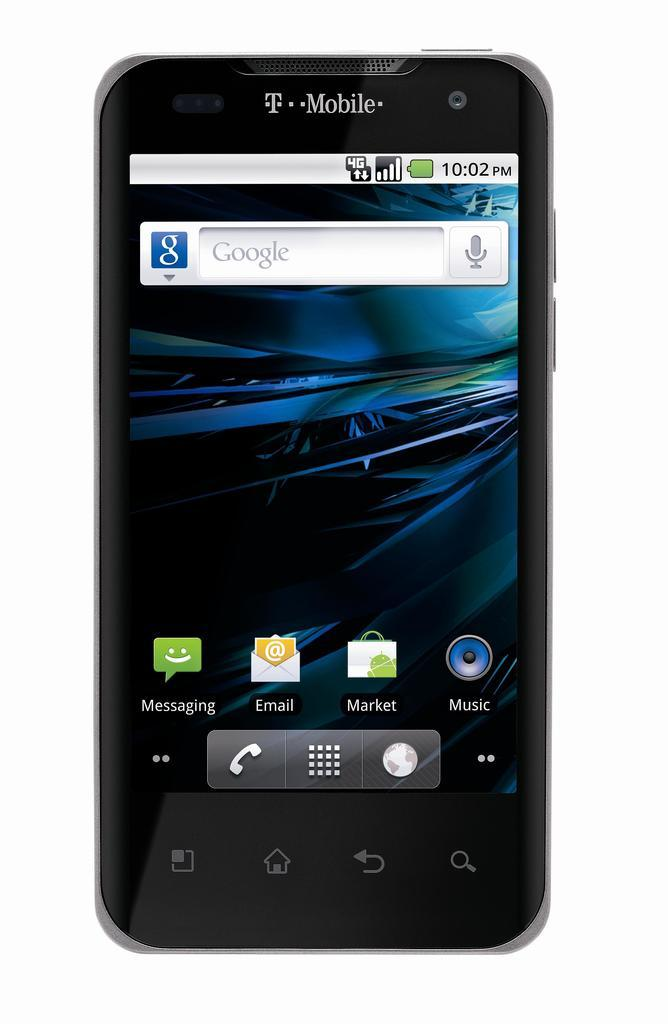<image>
Offer a succinct explanation of the picture presented. a phone that has an email icon on it 